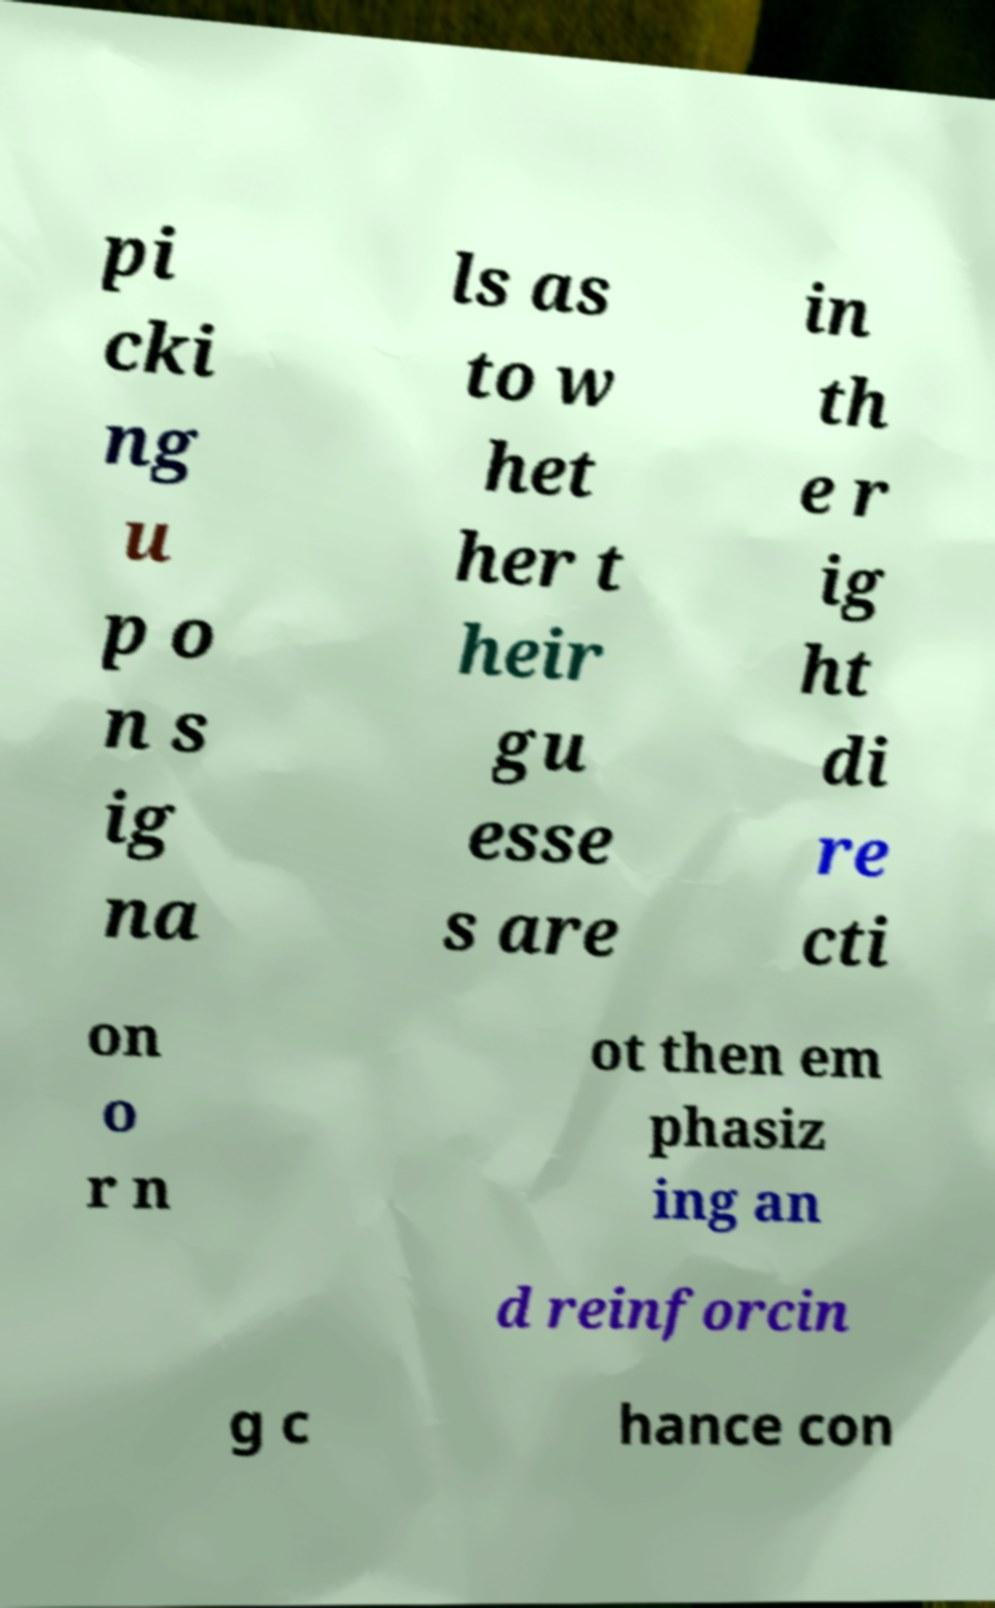There's text embedded in this image that I need extracted. Can you transcribe it verbatim? pi cki ng u p o n s ig na ls as to w het her t heir gu esse s are in th e r ig ht di re cti on o r n ot then em phasiz ing an d reinforcin g c hance con 